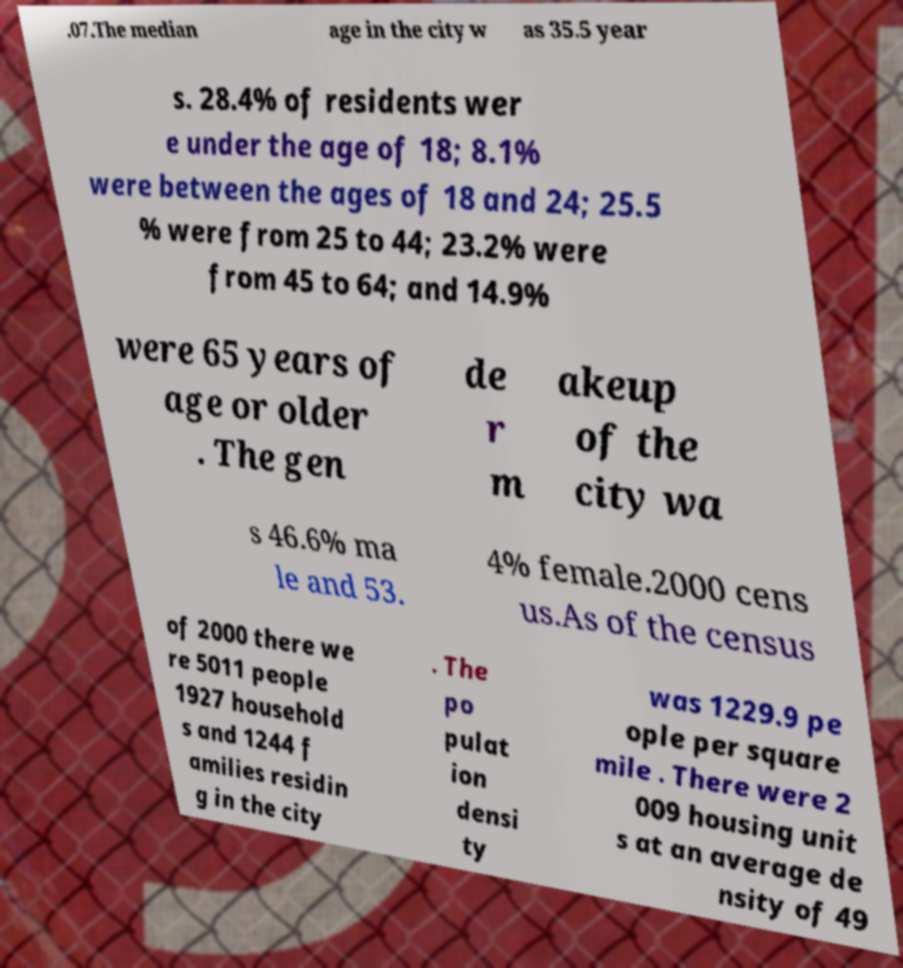Could you extract and type out the text from this image? .07.The median age in the city w as 35.5 year s. 28.4% of residents wer e under the age of 18; 8.1% were between the ages of 18 and 24; 25.5 % were from 25 to 44; 23.2% were from 45 to 64; and 14.9% were 65 years of age or older . The gen de r m akeup of the city wa s 46.6% ma le and 53. 4% female.2000 cens us.As of the census of 2000 there we re 5011 people 1927 household s and 1244 f amilies residin g in the city . The po pulat ion densi ty was 1229.9 pe ople per square mile . There were 2 009 housing unit s at an average de nsity of 49 